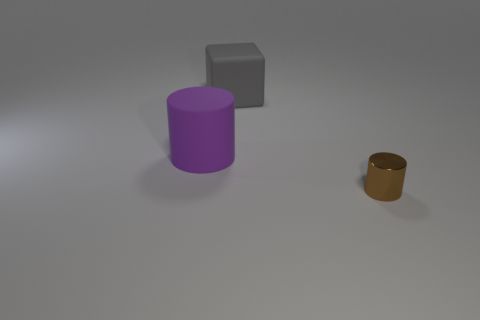Are there any tiny objects that have the same color as the large rubber cube?
Your answer should be compact. No. Is the number of brown cylinders behind the purple matte thing greater than the number of gray rubber things?
Provide a succinct answer. No. There is a tiny object; does it have the same shape as the big rubber object that is left of the gray cube?
Your answer should be compact. Yes. Are any large objects visible?
Keep it short and to the point. Yes. What number of tiny objects are either brown cylinders or green spheres?
Make the answer very short. 1. Is the number of purple cylinders that are in front of the tiny brown object greater than the number of purple matte things that are behind the large purple thing?
Your response must be concise. No. Is the material of the purple cylinder the same as the cylinder right of the big block?
Provide a succinct answer. No. The tiny metallic object is what color?
Provide a short and direct response. Brown. What is the shape of the rubber object on the right side of the large purple rubber cylinder?
Provide a succinct answer. Cube. How many brown things are either tiny rubber cylinders or metallic things?
Your answer should be compact. 1. 